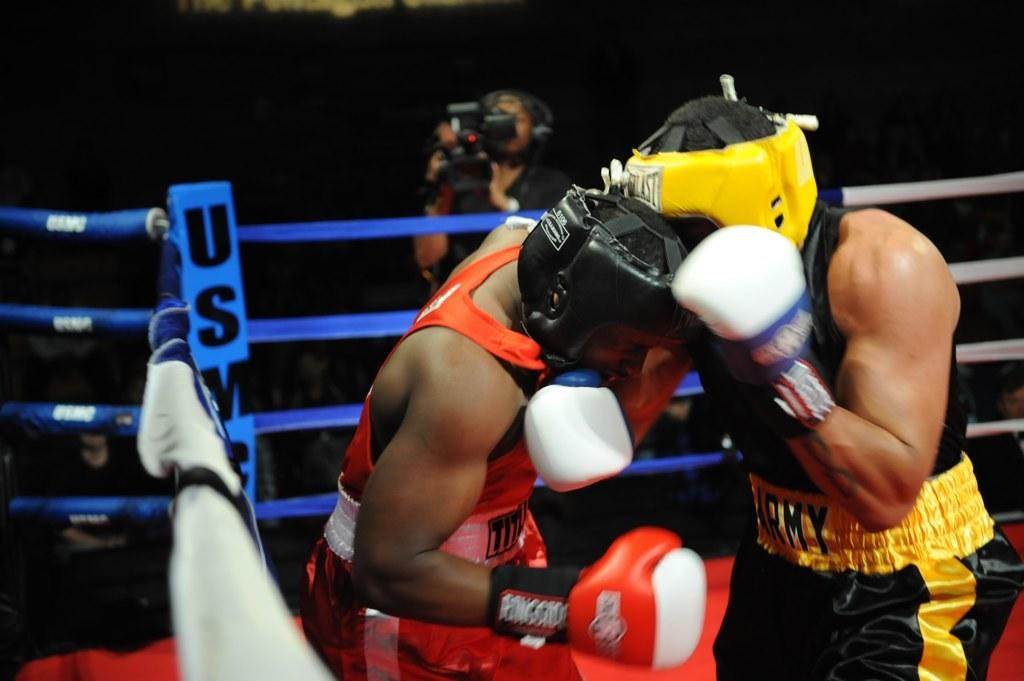What are the two men in the foreground of the image doing? The two men in the foreground of the image are boxing. What safety feature is present in the image? There is safety railing in the image. Who else can be seen in the image besides the two boxing men? A man holding a camera is visible in the image, and there are a few persons in the background. How would you describe the lighting in the image? The background appears to be dark. What flavor of food are the friends cooking in the image? There are no friends or cooking activity present in the image. 